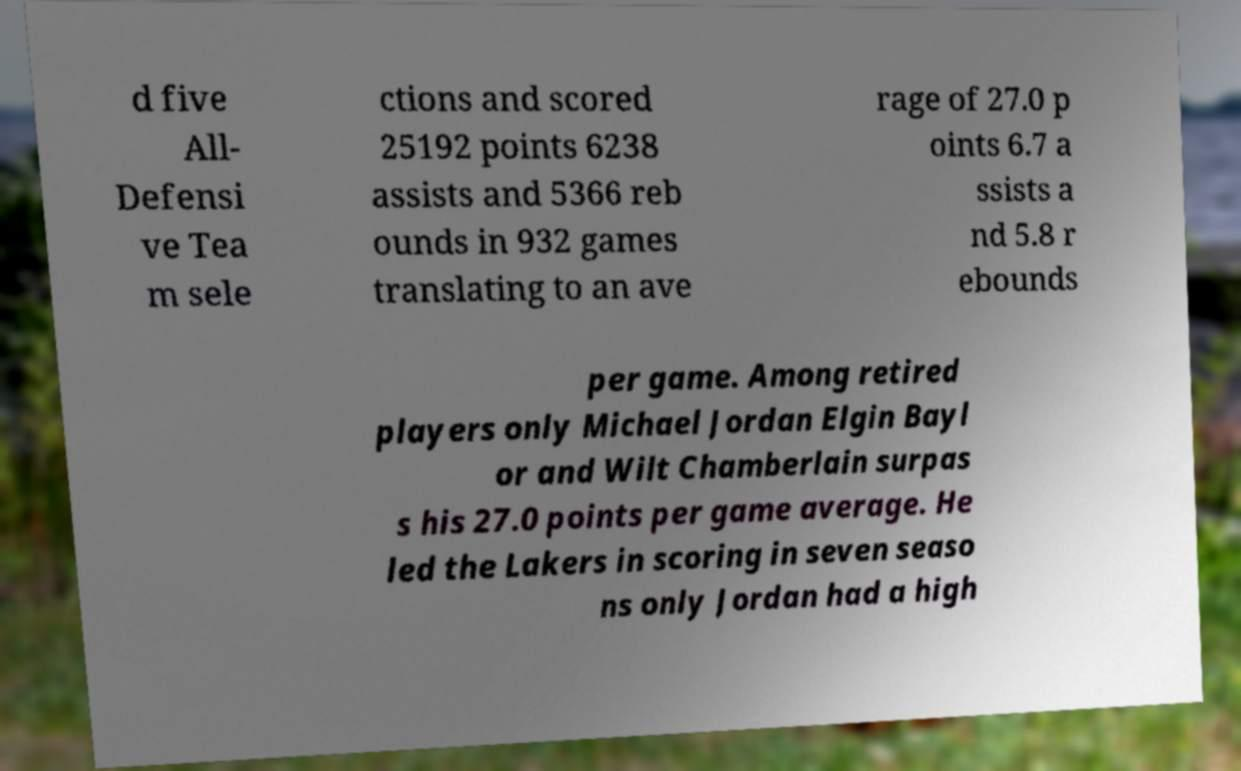Please identify and transcribe the text found in this image. d five All- Defensi ve Tea m sele ctions and scored 25192 points 6238 assists and 5366 reb ounds in 932 games translating to an ave rage of 27.0 p oints 6.7 a ssists a nd 5.8 r ebounds per game. Among retired players only Michael Jordan Elgin Bayl or and Wilt Chamberlain surpas s his 27.0 points per game average. He led the Lakers in scoring in seven seaso ns only Jordan had a high 